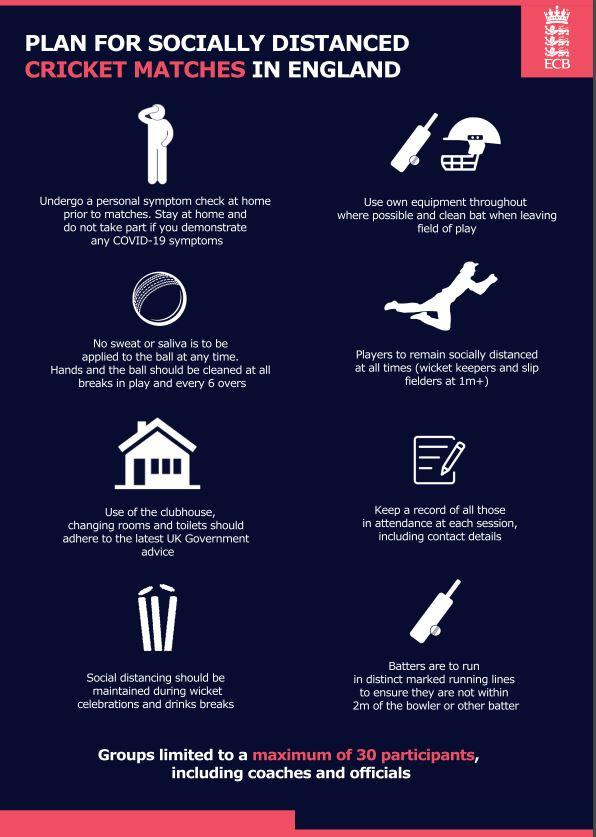Indicate a few pertinent items in this graphic. It is recommended to keep a distance of 2 meters from other players while running between the wickets. In the event of a batsman getting out, social distancing should be maintained during wicket celebrations to prevent the spread of COVID-19. The recommended frequency for cleaning the cricket ball is after every break in play and every six hours. 